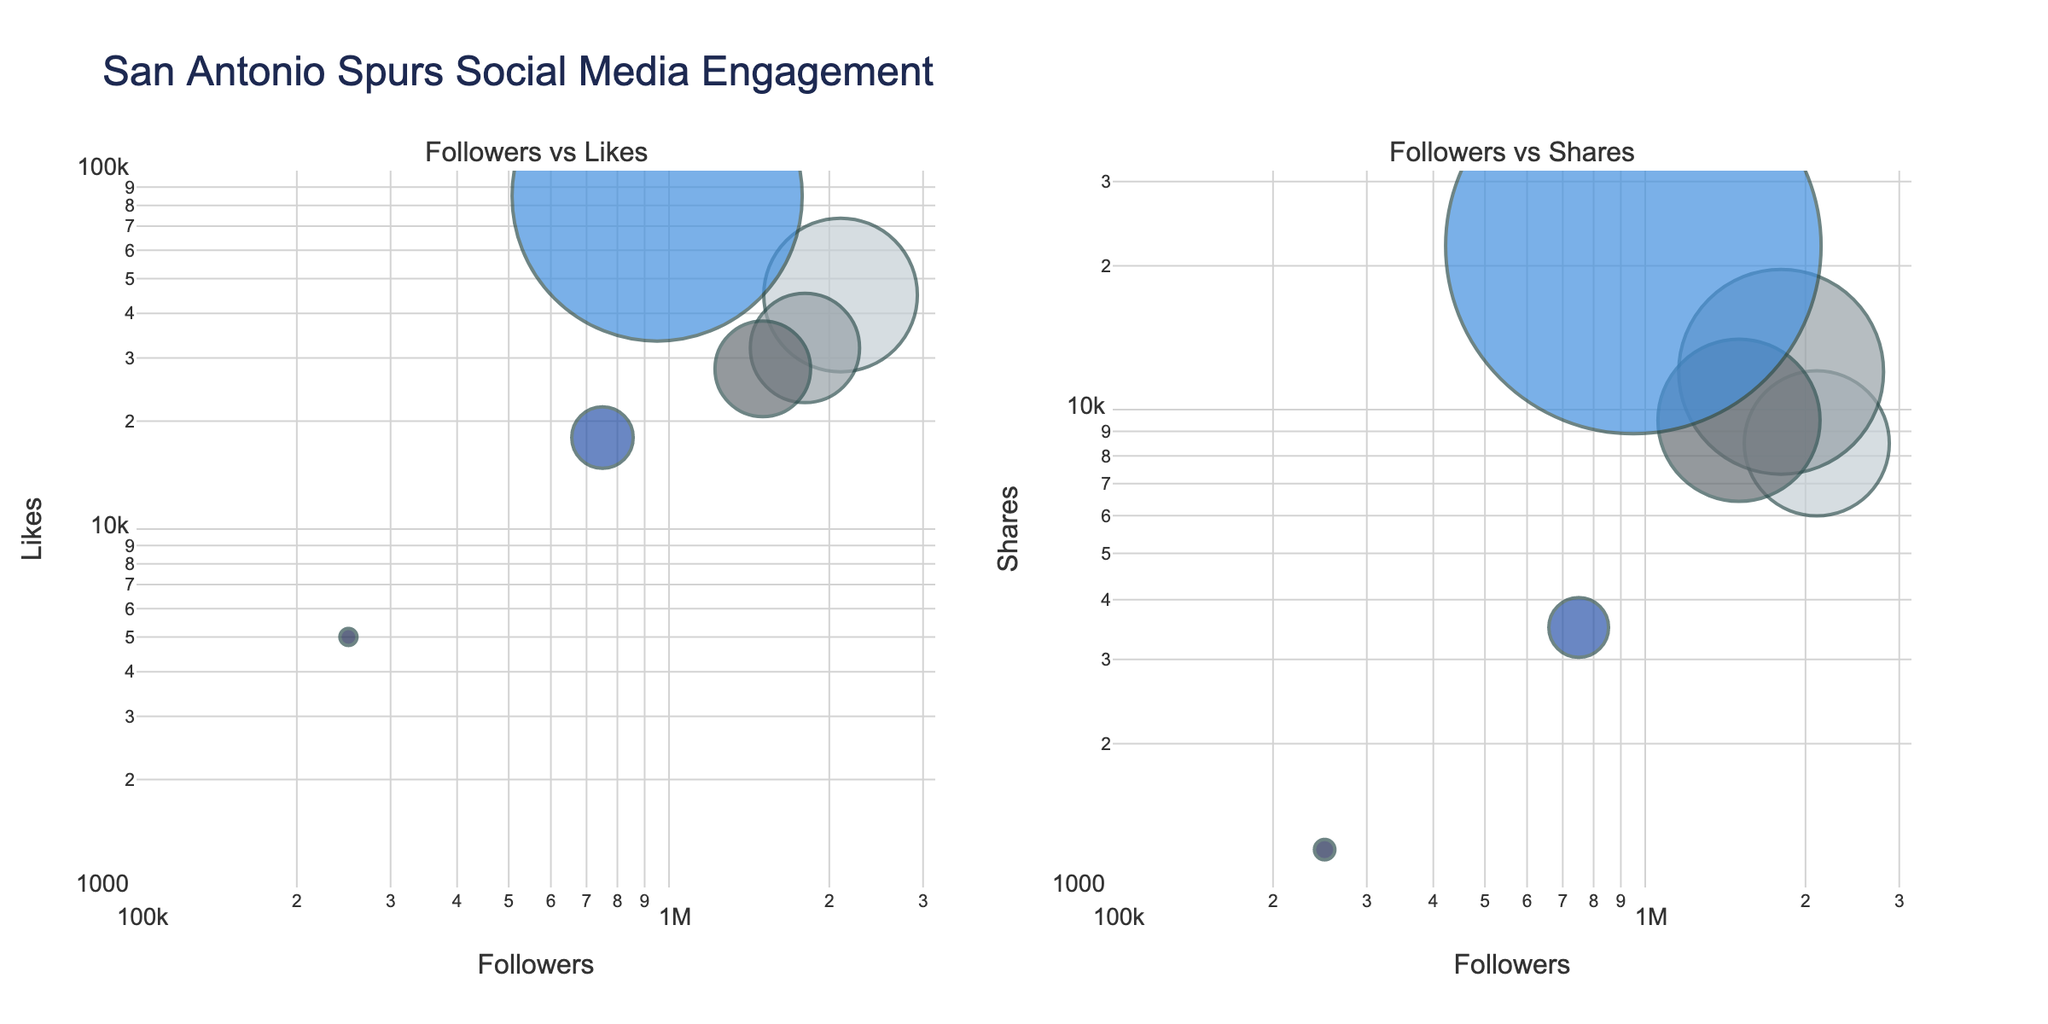What's the title of the figure? The title is usually prominently displayed at the top of the figure. In this case, we are told the title from the code, which is "San Antonio Spurs Social Media Engagement".
Answer: San Antonio Spurs Social Media Engagement How many platforms are displayed in the charts? To find the number of platforms, count the number of data points (bubbles) in either of the subplots. Each platform is represented once in each chart.
Answer: 6 Which platform has the highest number of likes relative to its number of followers? By examining the size of the bubbles on the "Followers vs Likes" subplot, we notice that TikTok has the largest bubble, indicating the highest ratio of likes to followers.
Answer: TikTok What is the logarithmic range of the x-axis representing followers? The axes ranges are usually shown on the subplot. In this case, the range for the followers is from 10^5 to 10^6.5, as indicated by the labels on the x-axis.
Answer: 10^5 to 10^6.5 Compare the number of shares for Twitter and Instagram. Which platform has more shares? The "Followers vs Shares" subplot shows us the relative size of the bubbles. By comparing these, we can see that Twitter has a larger bubble size, indicating more shares.
Answer: Twitter Which platform has the smallest bubble in the "Followers vs Likes" subplot, and what does this indicate? By looking at the smallest bubble size in the "Followers vs Likes" subplot, LinkedIn stands out. This indicates that LinkedIn has the lowest number of likes relative to its followers.
Answer: LinkedIn If you sum the number of followers for Instagram and Twitter, how many will you have? Add the number of followers for Instagram (2,100,000) and Twitter (1,800,000). The sum is 3,900,000.
Answer: 3,900,000 Does Facebook or YouTube have a higher number of shares? Compare the size of the bubbles in the "Followers vs Shares" subplot for Facebook and YouTube. Facebook has a larger bubble, indicating a higher number of shares.
Answer: Facebook Which platform appears to generate the highest engagement across likes and shares? By examining both subplots, TikTok has the most prominent bubble sizes in both the "Followers vs Likes" and "Followers vs Shares" charts. This suggests TikTok generates the highest engagement.
Answer: TikTok What color is used for the Instagram bubble, and what might be the reason for this selection? By referring to the colors defined and viewing the chart, we can match the colors. Instagram is likely purple/blue (#418FDE), fitting the Spurs' team colors. The detailed data supports using team colors for a coherent theme.
Answer: Purple/Blue 